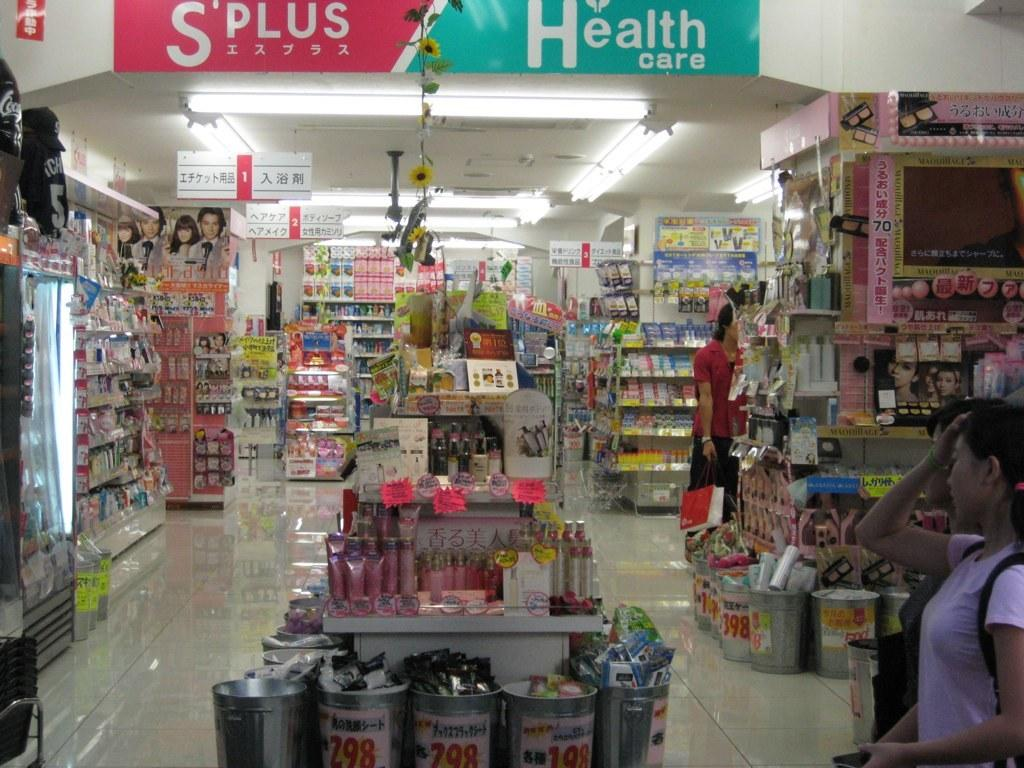<image>
Present a compact description of the photo's key features. A girl in pink entering a S'Plus Health care store near a display surrounded by metal buckets. 